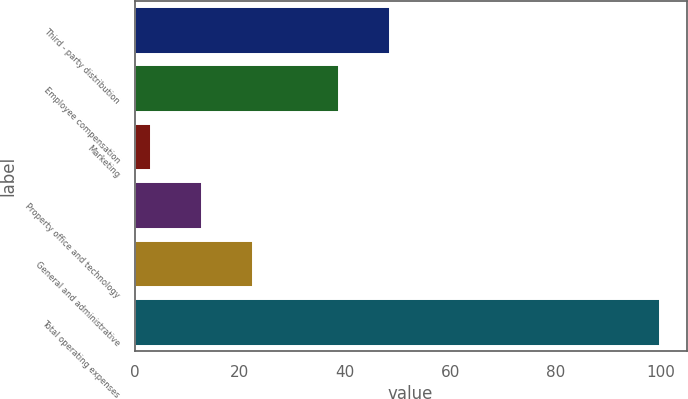Convert chart to OTSL. <chart><loc_0><loc_0><loc_500><loc_500><bar_chart><fcel>Third - party distribution<fcel>Employee compensation<fcel>Marketing<fcel>Property office and technology<fcel>General and administrative<fcel>Total operating expenses<nl><fcel>48.48<fcel>38.8<fcel>3.2<fcel>12.88<fcel>22.56<fcel>100<nl></chart> 